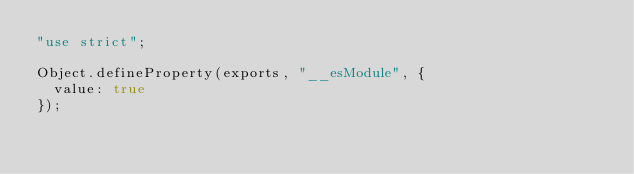Convert code to text. <code><loc_0><loc_0><loc_500><loc_500><_JavaScript_>"use strict";

Object.defineProperty(exports, "__esModule", {
  value: true
});</code> 